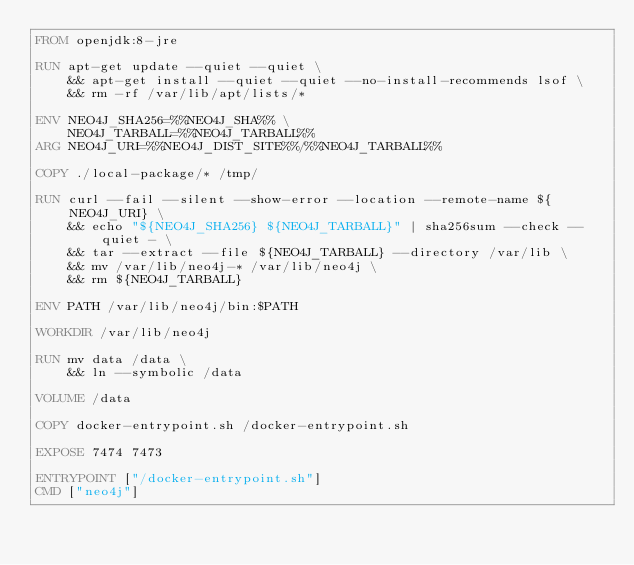<code> <loc_0><loc_0><loc_500><loc_500><_Dockerfile_>FROM openjdk:8-jre

RUN apt-get update --quiet --quiet \
    && apt-get install --quiet --quiet --no-install-recommends lsof \
    && rm -rf /var/lib/apt/lists/*

ENV NEO4J_SHA256=%%NEO4J_SHA%% \
    NEO4J_TARBALL=%%NEO4J_TARBALL%%
ARG NEO4J_URI=%%NEO4J_DIST_SITE%%/%%NEO4J_TARBALL%%

COPY ./local-package/* /tmp/

RUN curl --fail --silent --show-error --location --remote-name ${NEO4J_URI} \
    && echo "${NEO4J_SHA256} ${NEO4J_TARBALL}" | sha256sum --check --quiet - \
    && tar --extract --file ${NEO4J_TARBALL} --directory /var/lib \
    && mv /var/lib/neo4j-* /var/lib/neo4j \
    && rm ${NEO4J_TARBALL}

ENV PATH /var/lib/neo4j/bin:$PATH

WORKDIR /var/lib/neo4j

RUN mv data /data \
    && ln --symbolic /data

VOLUME /data

COPY docker-entrypoint.sh /docker-entrypoint.sh

EXPOSE 7474 7473

ENTRYPOINT ["/docker-entrypoint.sh"]
CMD ["neo4j"]
</code> 